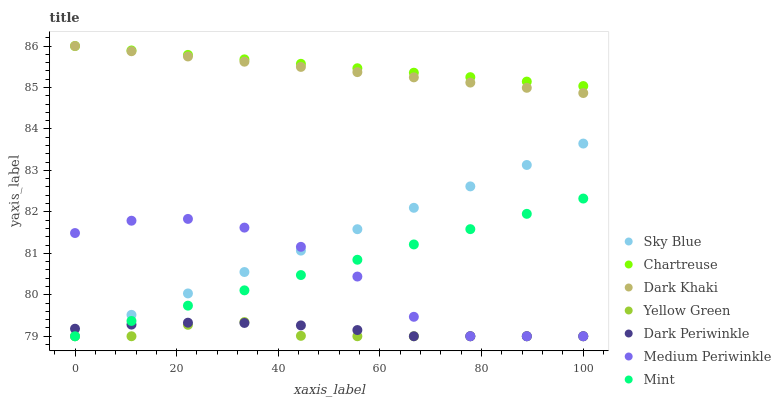Does Yellow Green have the minimum area under the curve?
Answer yes or no. Yes. Does Chartreuse have the maximum area under the curve?
Answer yes or no. Yes. Does Medium Periwinkle have the minimum area under the curve?
Answer yes or no. No. Does Medium Periwinkle have the maximum area under the curve?
Answer yes or no. No. Is Chartreuse the smoothest?
Answer yes or no. Yes. Is Medium Periwinkle the roughest?
Answer yes or no. Yes. Is Dark Khaki the smoothest?
Answer yes or no. No. Is Dark Khaki the roughest?
Answer yes or no. No. Does Yellow Green have the lowest value?
Answer yes or no. Yes. Does Dark Khaki have the lowest value?
Answer yes or no. No. Does Chartreuse have the highest value?
Answer yes or no. Yes. Does Medium Periwinkle have the highest value?
Answer yes or no. No. Is Mint less than Dark Khaki?
Answer yes or no. Yes. Is Dark Khaki greater than Medium Periwinkle?
Answer yes or no. Yes. Does Mint intersect Medium Periwinkle?
Answer yes or no. Yes. Is Mint less than Medium Periwinkle?
Answer yes or no. No. Is Mint greater than Medium Periwinkle?
Answer yes or no. No. Does Mint intersect Dark Khaki?
Answer yes or no. No. 